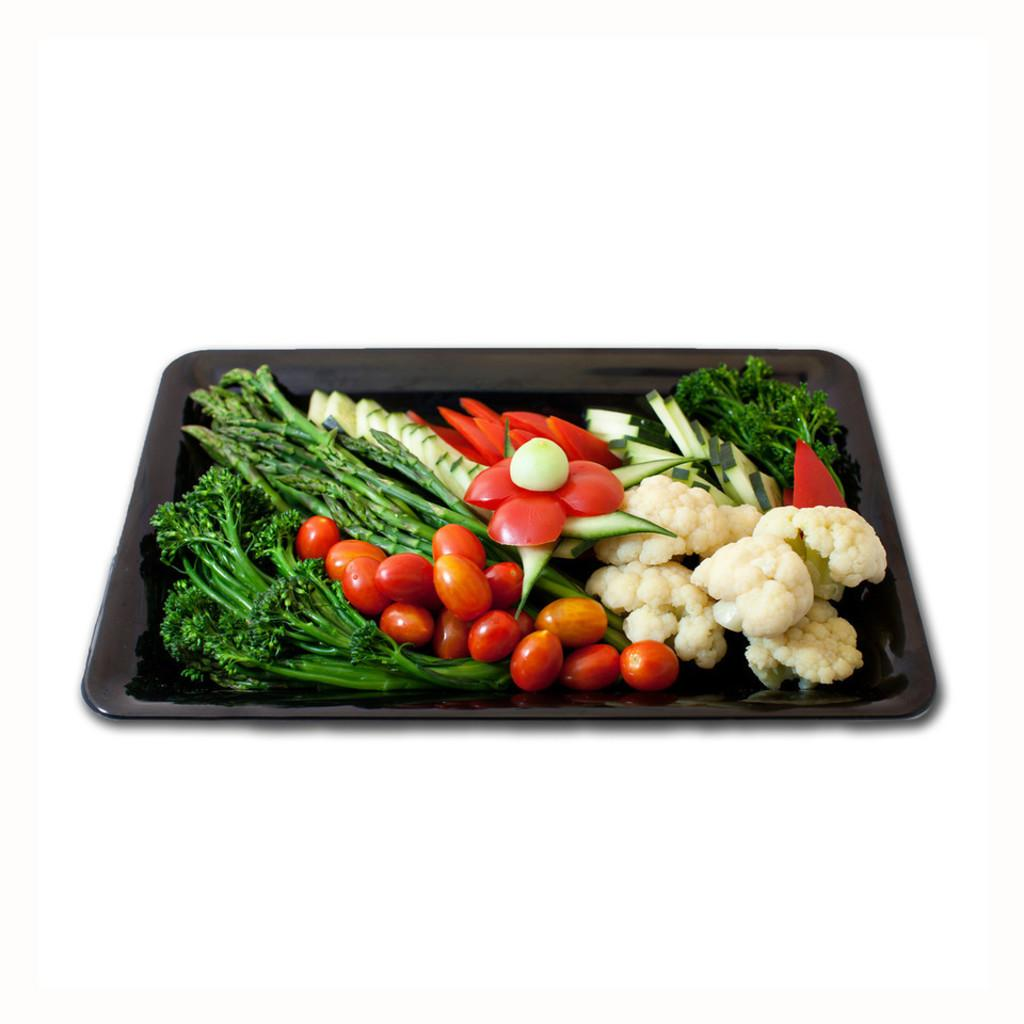What object is present in the image that can hold items? There is a tray in the image that can hold items. What type of food can be seen on the tray? There are tomatoes, cauliflower, and cucumber slices on the tray. What category of vegetables is present on the tray? There are green vegetables on the tray. What statement is written on the sheet in the image? There is no sheet or statement present in the image; it only features a tray with vegetables. How many chickens are visible in the image? There are no chickens present in the image; it only features a tray with vegetables. 